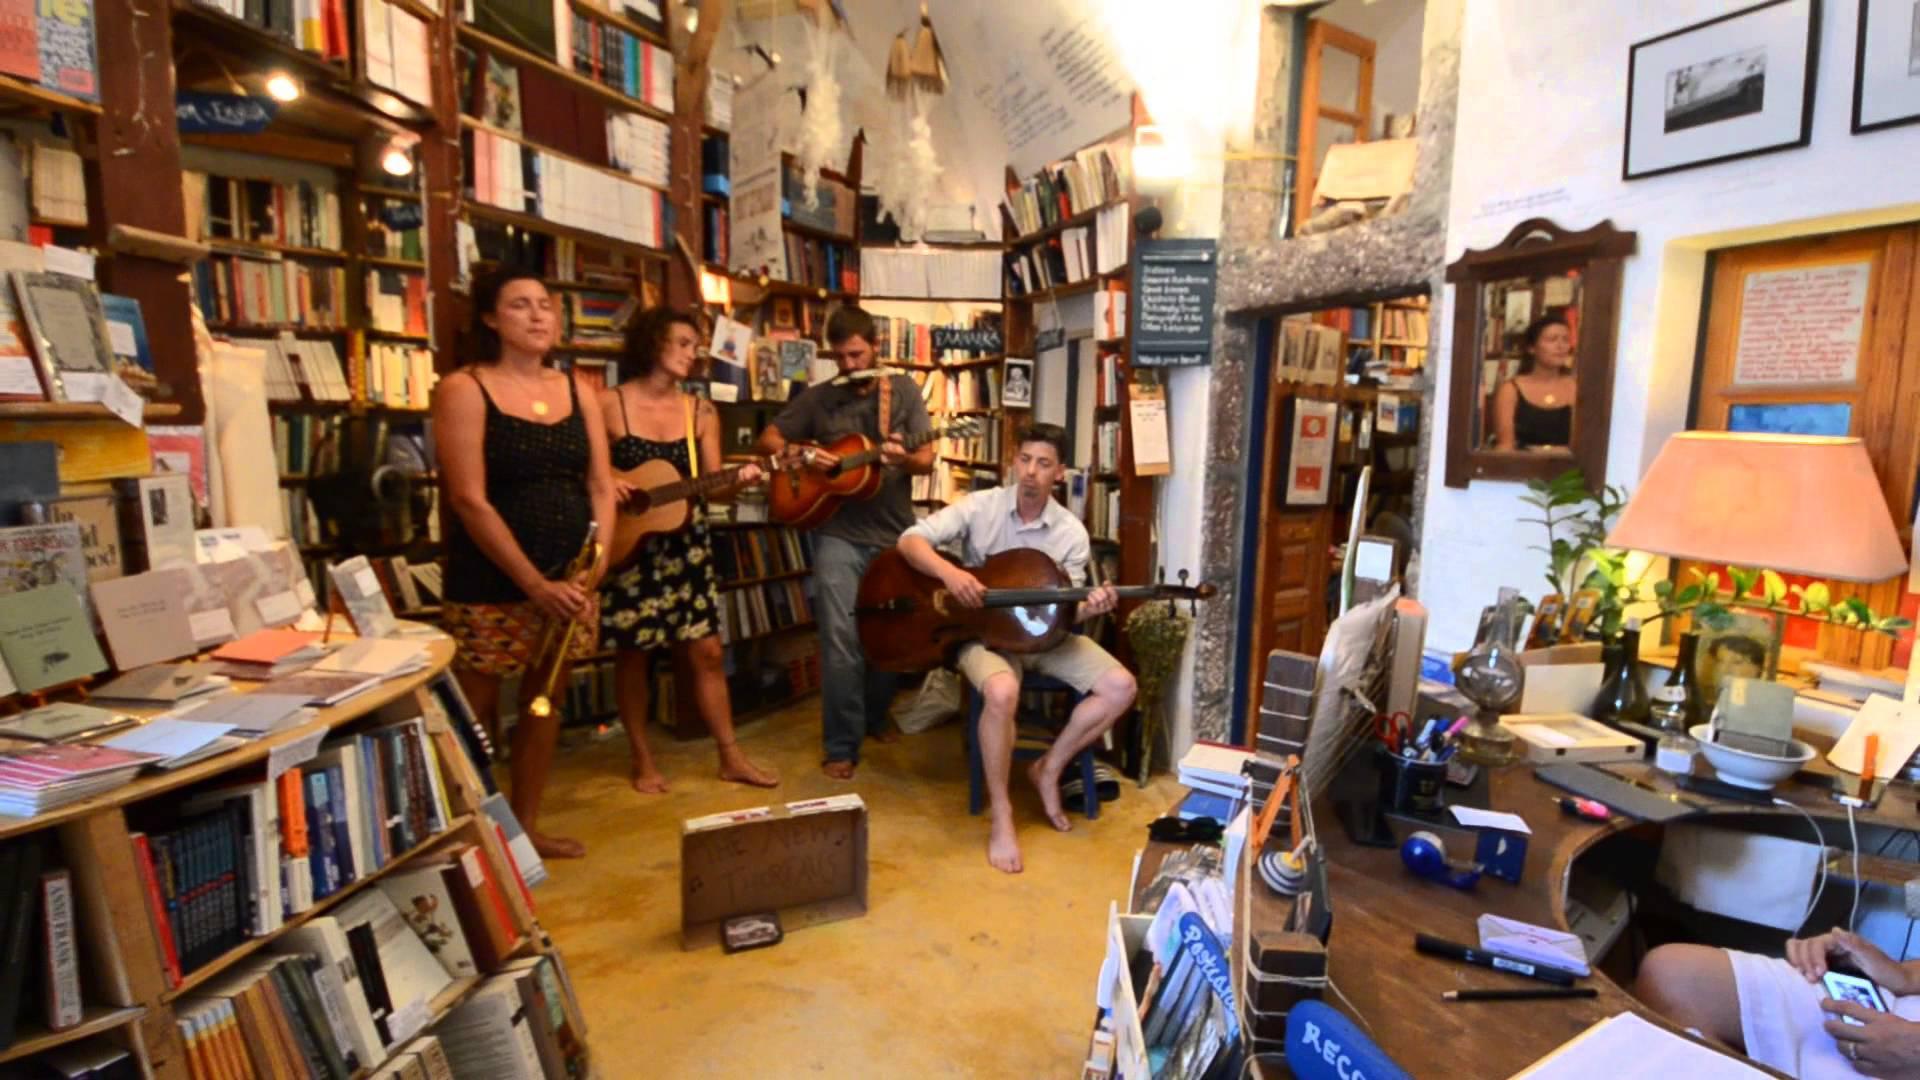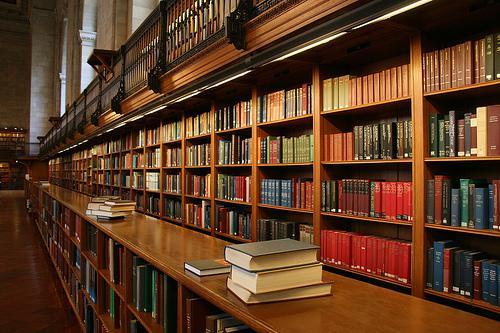The first image is the image on the left, the second image is the image on the right. Assess this claim about the two images: "At least one person is near the bookstore in one of the images.". Correct or not? Answer yes or no. Yes. 